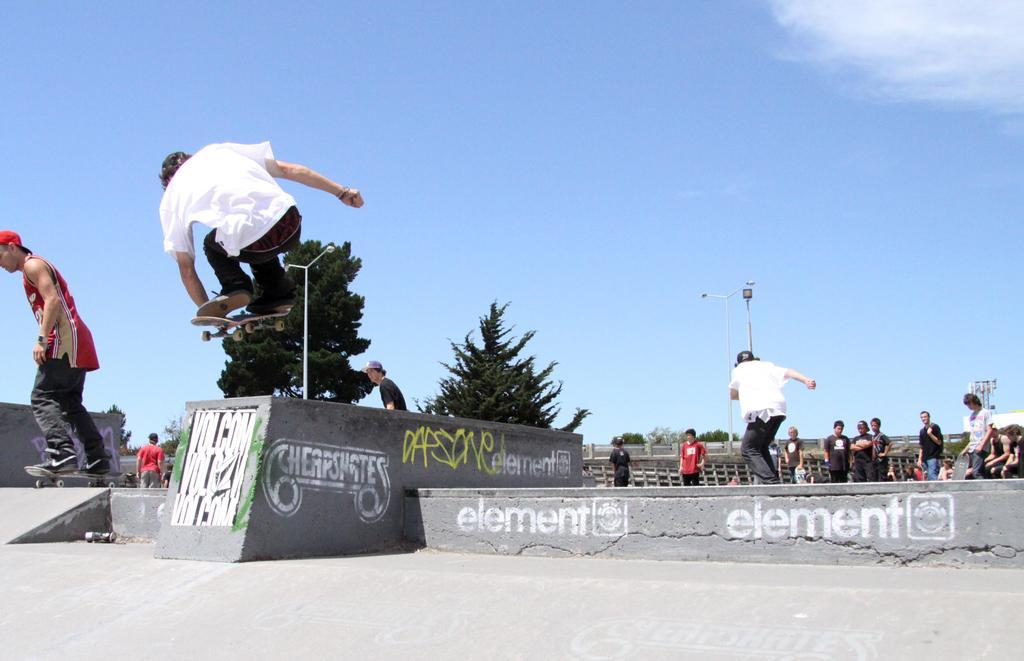Can you describe this image briefly? In this picture we can see two men on skateboards and a man is in the air. In the background we can see a group of people, trees, light poles, fence, some objects and the sky. 